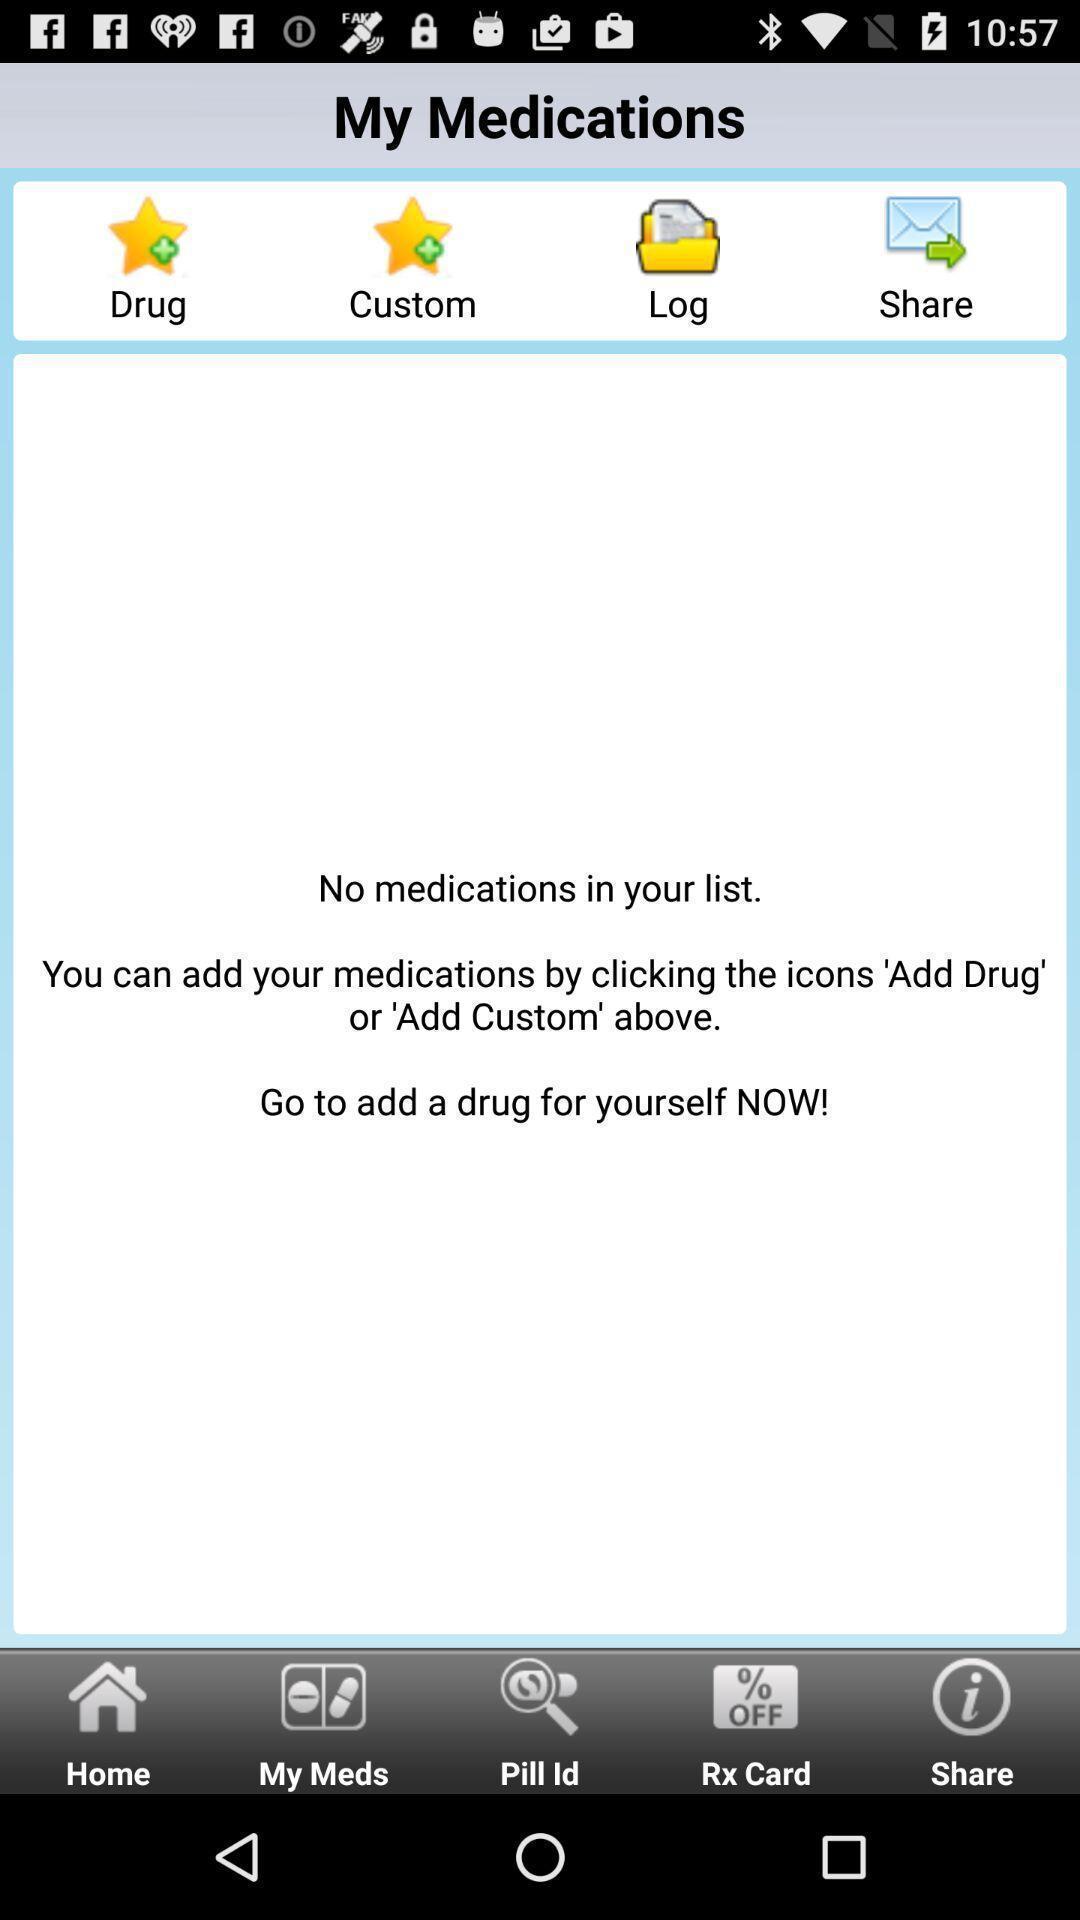Provide a description of this screenshot. Screen shows no medications in a list. 